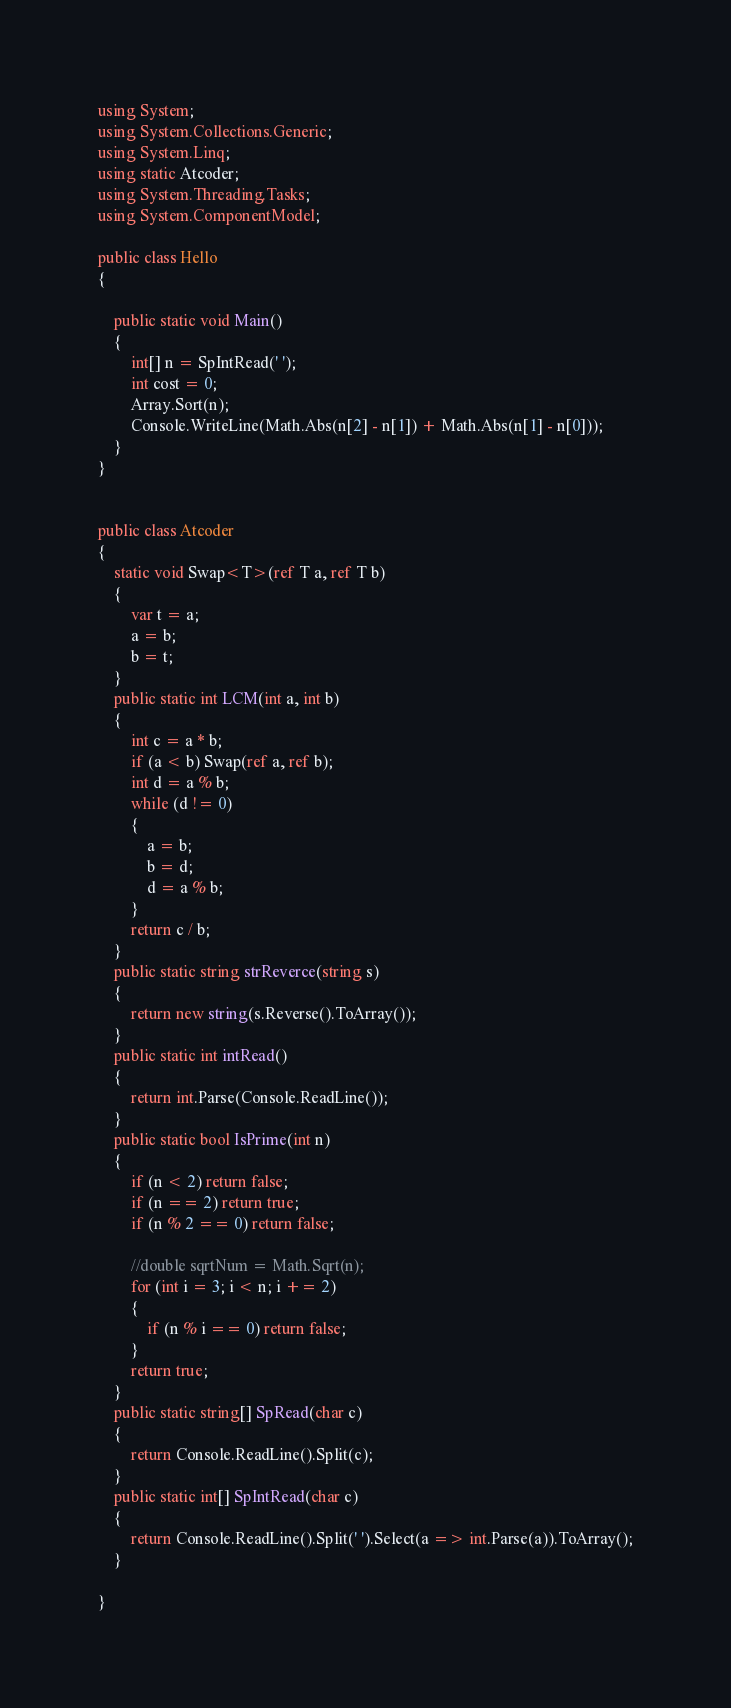Convert code to text. <code><loc_0><loc_0><loc_500><loc_500><_C#_>using System;
using System.Collections.Generic;
using System.Linq;
using static Atcoder;
using System.Threading.Tasks;
using System.ComponentModel;

public class Hello
{

    public static void Main()
    {
        int[] n = SpIntRead(' ');
        int cost = 0;
        Array.Sort(n);
        Console.WriteLine(Math.Abs(n[2] - n[1]) + Math.Abs(n[1] - n[0]));
    }
}


public class Atcoder
{
    static void Swap<T>(ref T a, ref T b)
    {
        var t = a;
        a = b;
        b = t;
    }
    public static int LCM(int a, int b)
    {
        int c = a * b;
        if (a < b) Swap(ref a, ref b);
        int d = a % b;
        while (d != 0)
        {
            a = b;
            b = d;
            d = a % b;
        }
        return c / b;
    }
    public static string strReverce(string s)
    {
        return new string(s.Reverse().ToArray());
    }
    public static int intRead()
    {
        return int.Parse(Console.ReadLine());
    }
    public static bool IsPrime(int n)
    {
        if (n < 2) return false;
        if (n == 2) return true;
        if (n % 2 == 0) return false;

        //double sqrtNum = Math.Sqrt(n);
        for (int i = 3; i < n; i += 2)
        {
            if (n % i == 0) return false;
        }
        return true;
    }
    public static string[] SpRead(char c)
    {
        return Console.ReadLine().Split(c);
    }
    public static int[] SpIntRead(char c)
    {
        return Console.ReadLine().Split(' ').Select(a => int.Parse(a)).ToArray();
    }

}
</code> 